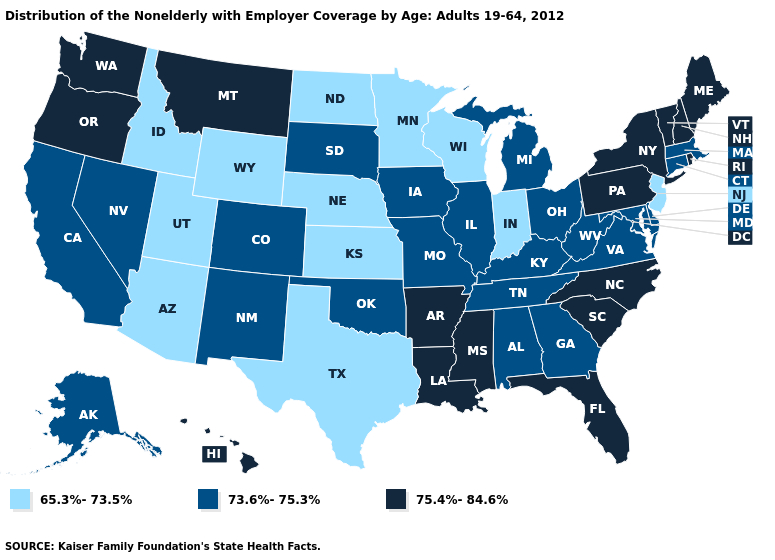What is the highest value in the Northeast ?
Write a very short answer. 75.4%-84.6%. Does the map have missing data?
Answer briefly. No. Name the states that have a value in the range 65.3%-73.5%?
Concise answer only. Arizona, Idaho, Indiana, Kansas, Minnesota, Nebraska, New Jersey, North Dakota, Texas, Utah, Wisconsin, Wyoming. What is the highest value in the USA?
Quick response, please. 75.4%-84.6%. Among the states that border Ohio , does Pennsylvania have the highest value?
Keep it brief. Yes. Is the legend a continuous bar?
Concise answer only. No. Which states hav the highest value in the South?
Concise answer only. Arkansas, Florida, Louisiana, Mississippi, North Carolina, South Carolina. Does the first symbol in the legend represent the smallest category?
Be succinct. Yes. Does Colorado have the same value as Washington?
Short answer required. No. Name the states that have a value in the range 73.6%-75.3%?
Write a very short answer. Alabama, Alaska, California, Colorado, Connecticut, Delaware, Georgia, Illinois, Iowa, Kentucky, Maryland, Massachusetts, Michigan, Missouri, Nevada, New Mexico, Ohio, Oklahoma, South Dakota, Tennessee, Virginia, West Virginia. Does the map have missing data?
Short answer required. No. How many symbols are there in the legend?
Short answer required. 3. What is the value of Virginia?
Write a very short answer. 73.6%-75.3%. Does New Jersey have the lowest value in the Northeast?
Short answer required. Yes. 